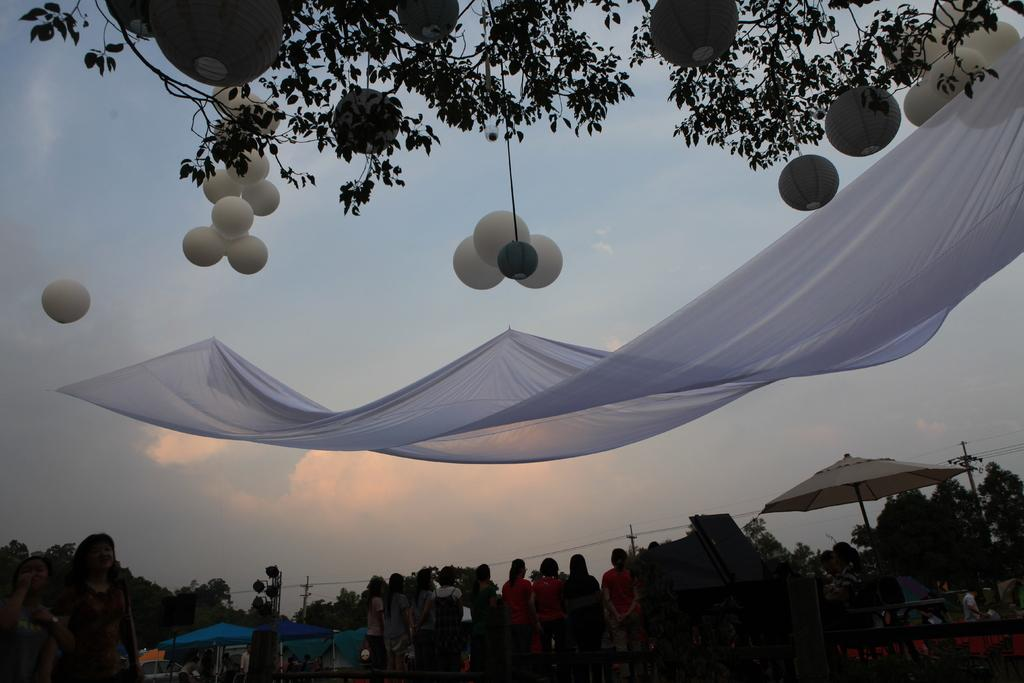Who or what is present in the image? There are people in the image. What objects are being used by the people in the image? There are umbrellas in the image. What color is the cloth visible in the image? There is a white color cloth in the image. What additional decorative items can be seen in the image? There are balloons in the image. What type of natural elements are present in the image? There are trees in the image. What flavor of whip is being served in the image? There is no whip present in the image, so it is not possible to determine the flavor. 